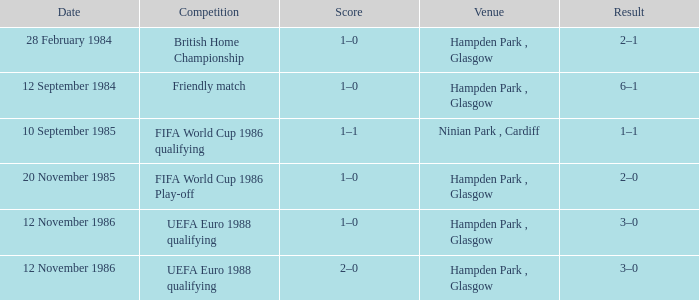What is the Score of the Fifa World Cup 1986 Play-off Competition? 1–0. 